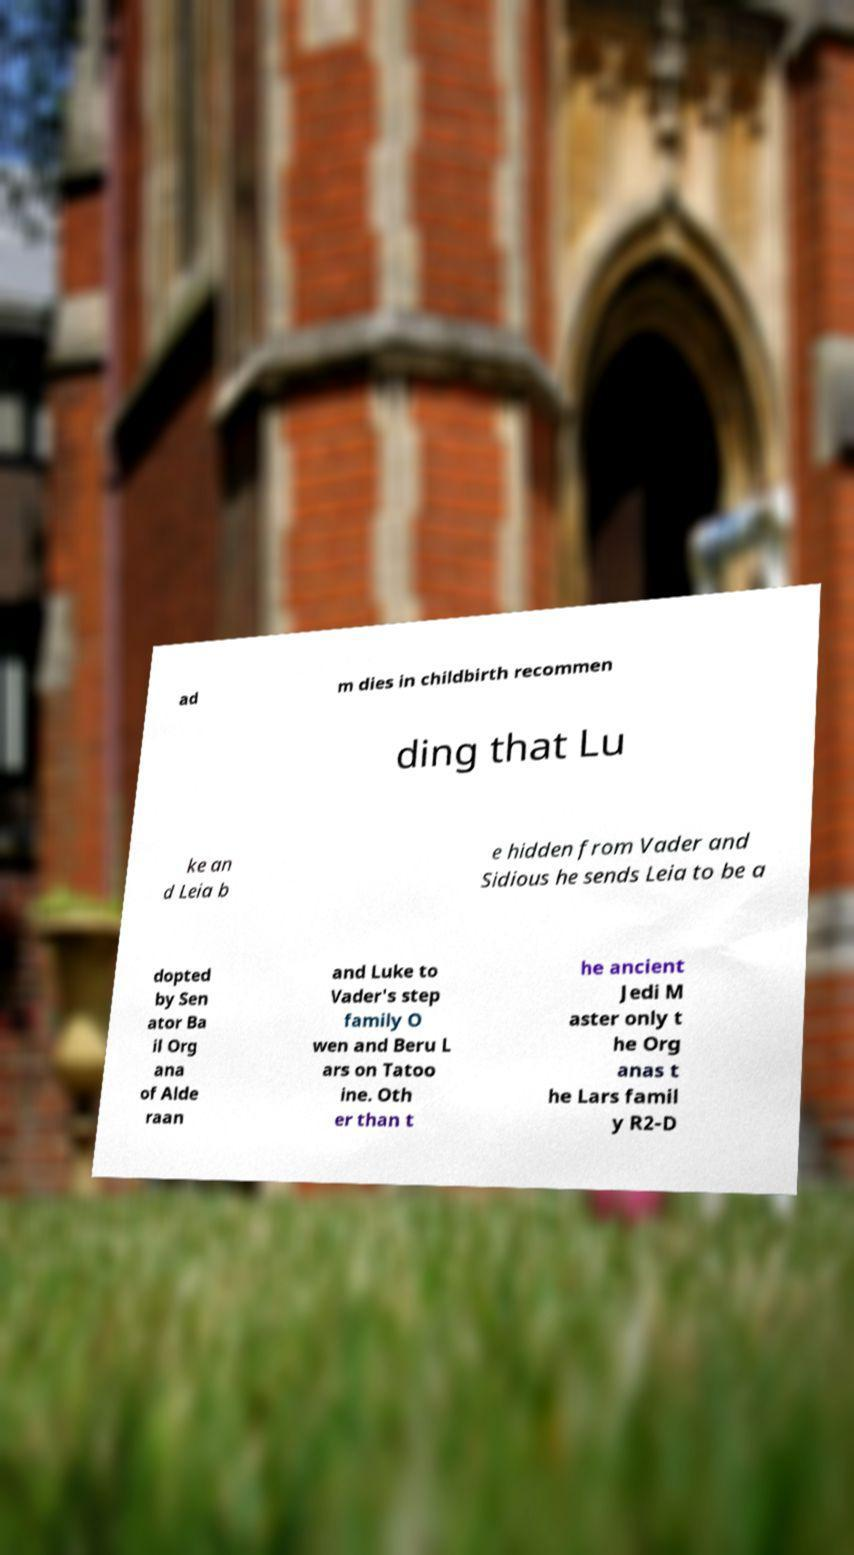For documentation purposes, I need the text within this image transcribed. Could you provide that? ad m dies in childbirth recommen ding that Lu ke an d Leia b e hidden from Vader and Sidious he sends Leia to be a dopted by Sen ator Ba il Org ana of Alde raan and Luke to Vader's step family O wen and Beru L ars on Tatoo ine. Oth er than t he ancient Jedi M aster only t he Org anas t he Lars famil y R2-D 